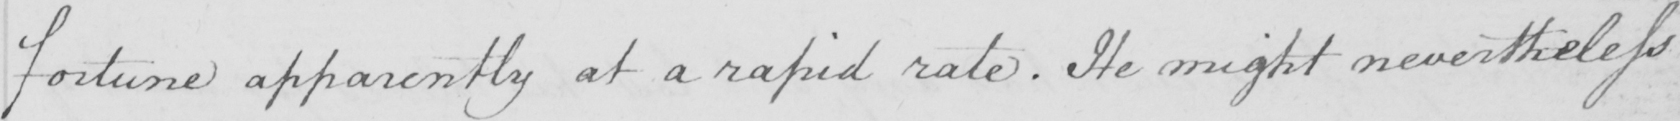What is written in this line of handwriting? fortune apparently at a rapid rate . He might nevertheless 